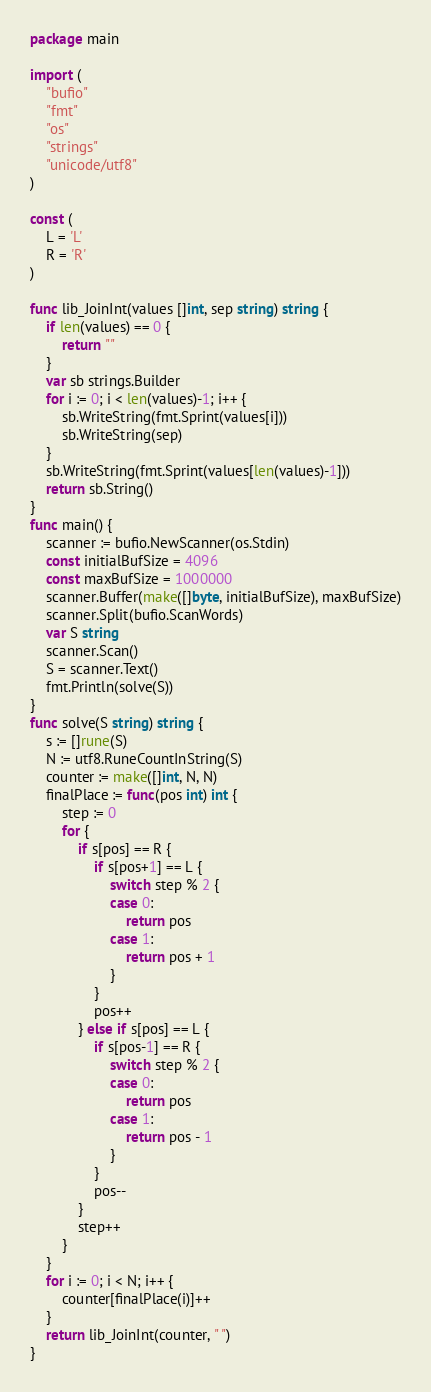Convert code to text. <code><loc_0><loc_0><loc_500><loc_500><_Go_>package main

import (
	"bufio"
	"fmt"
	"os"
	"strings"
	"unicode/utf8"
)

const (
	L = 'L'
	R = 'R'
)

func lib_JoinInt(values []int, sep string) string {
	if len(values) == 0 {
		return ""
	}
	var sb strings.Builder
	for i := 0; i < len(values)-1; i++ {
		sb.WriteString(fmt.Sprint(values[i]))
		sb.WriteString(sep)
	}
	sb.WriteString(fmt.Sprint(values[len(values)-1]))
	return sb.String()
}
func main() {
	scanner := bufio.NewScanner(os.Stdin)
	const initialBufSize = 4096
	const maxBufSize = 1000000
	scanner.Buffer(make([]byte, initialBufSize), maxBufSize)
	scanner.Split(bufio.ScanWords)
	var S string
	scanner.Scan()
	S = scanner.Text()
	fmt.Println(solve(S))
}
func solve(S string) string {
	s := []rune(S)
	N := utf8.RuneCountInString(S)
	counter := make([]int, N, N)
	finalPlace := func(pos int) int {
		step := 0
		for {
			if s[pos] == R {
				if s[pos+1] == L {
					switch step % 2 {
					case 0:
						return pos
					case 1:
						return pos + 1
					}
				}
				pos++
			} else if s[pos] == L {
				if s[pos-1] == R {
					switch step % 2 {
					case 0:
						return pos
					case 1:
						return pos - 1
					}
				}
				pos--
			}
			step++
		}
	}
	for i := 0; i < N; i++ {
		counter[finalPlace(i)]++
	}
	return lib_JoinInt(counter, " ")
}
</code> 